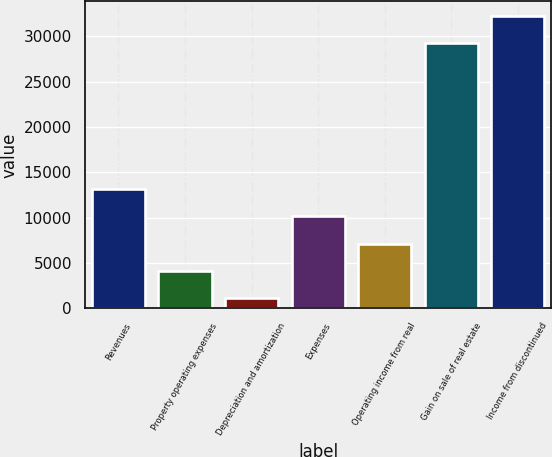Convert chart. <chart><loc_0><loc_0><loc_500><loc_500><bar_chart><fcel>Revenues<fcel>Property operating expenses<fcel>Depreciation and amortization<fcel>Expenses<fcel>Operating income from real<fcel>Gain on sale of real estate<fcel>Income from discontinued<nl><fcel>13128<fcel>4105.5<fcel>1098<fcel>10120.5<fcel>7113<fcel>29223<fcel>32230.5<nl></chart> 